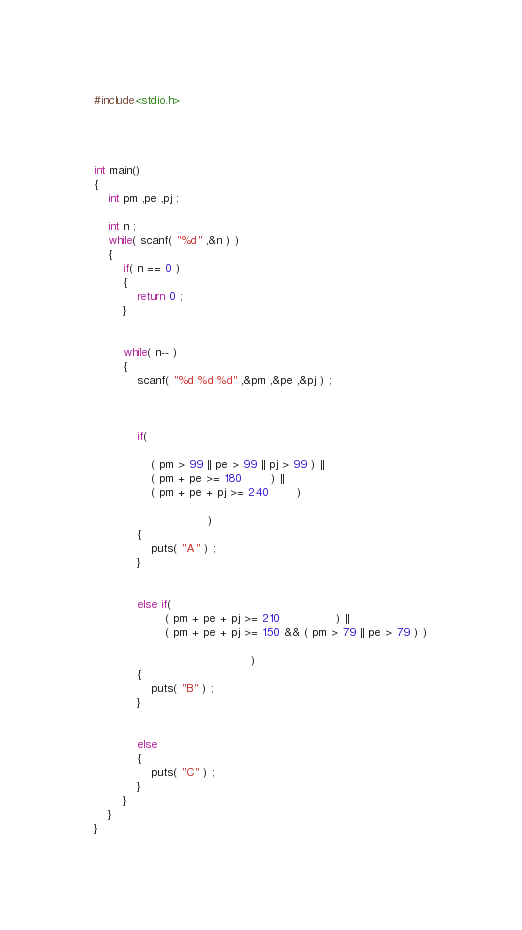Convert code to text. <code><loc_0><loc_0><loc_500><loc_500><_C_>#include<stdio.h>




int main()
{
	int pm ,pe ,pj ;

	int n ;
	while( scanf( "%d" ,&n ) )
	{
		if( n == 0 )
		{
			return 0 ;
		}


		while( n-- )
		{
			scanf( "%d %d %d" ,&pm ,&pe ,&pj ) ;



			if(

				( pm > 99 || pe > 99 || pj > 99 ) ||
				( pm + pe >= 180 		) ||
				( pm + pe + pj >= 240		)

								)
			{
				puts( "A" ) ;
			}


			else if(
					( pm + pe + pj >= 210 				) ||
					( pm + pe + pj >= 150 && ( pm > 79 || pe > 79 ) )

											)
			{
				puts( "B" ) ;
			}


			else
			{
				puts( "C" ) ;
			}
		}
	}
}</code> 